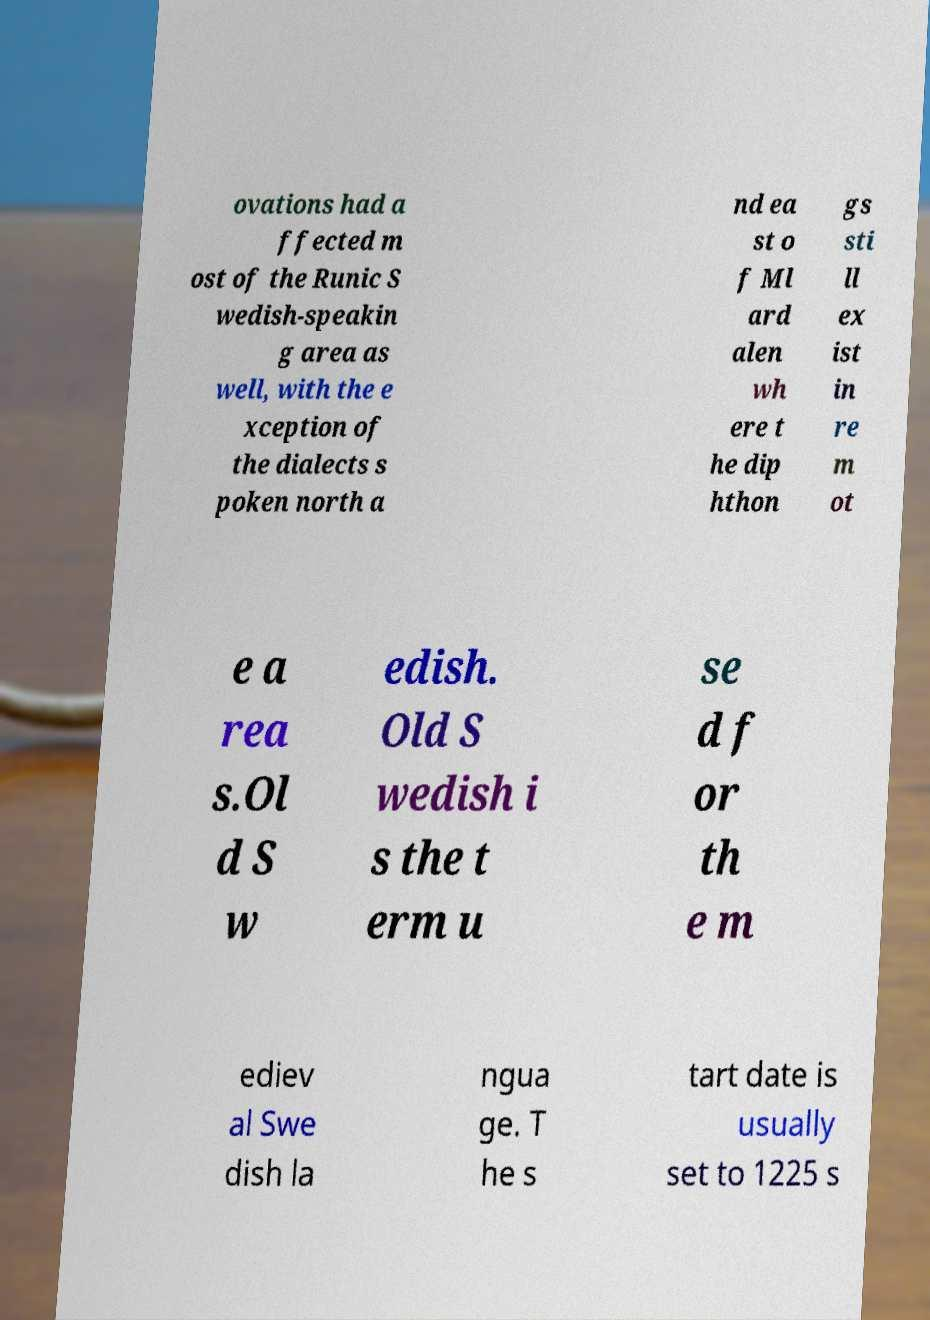Could you assist in decoding the text presented in this image and type it out clearly? ovations had a ffected m ost of the Runic S wedish-speakin g area as well, with the e xception of the dialects s poken north a nd ea st o f Ml ard alen wh ere t he dip hthon gs sti ll ex ist in re m ot e a rea s.Ol d S w edish. Old S wedish i s the t erm u se d f or th e m ediev al Swe dish la ngua ge. T he s tart date is usually set to 1225 s 